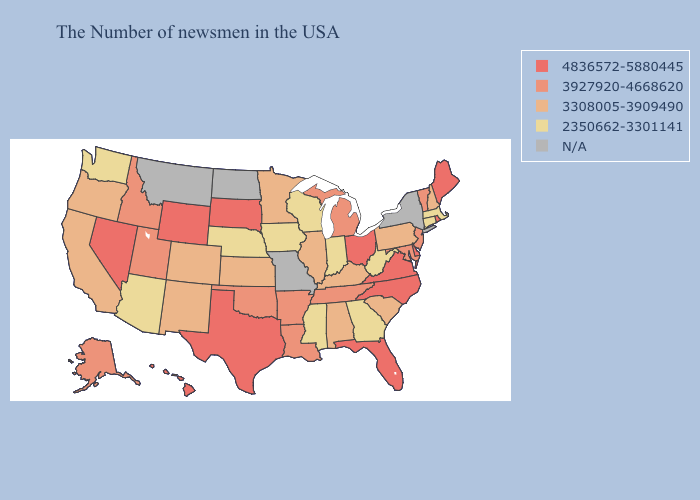What is the highest value in states that border Louisiana?
Concise answer only. 4836572-5880445. Name the states that have a value in the range 3308005-3909490?
Quick response, please. New Hampshire, Pennsylvania, South Carolina, Kentucky, Alabama, Illinois, Minnesota, Kansas, Colorado, New Mexico, California, Oregon. Does the map have missing data?
Write a very short answer. Yes. Among the states that border Indiana , which have the highest value?
Quick response, please. Ohio. Name the states that have a value in the range N/A?
Concise answer only. New York, Missouri, North Dakota, Montana. What is the lowest value in the South?
Short answer required. 2350662-3301141. What is the value of Delaware?
Answer briefly. 4836572-5880445. Does the first symbol in the legend represent the smallest category?
Quick response, please. No. What is the value of Iowa?
Short answer required. 2350662-3301141. What is the value of Hawaii?
Write a very short answer. 4836572-5880445. Name the states that have a value in the range 3308005-3909490?
Answer briefly. New Hampshire, Pennsylvania, South Carolina, Kentucky, Alabama, Illinois, Minnesota, Kansas, Colorado, New Mexico, California, Oregon. What is the value of Wyoming?
Give a very brief answer. 4836572-5880445. Name the states that have a value in the range 3308005-3909490?
Concise answer only. New Hampshire, Pennsylvania, South Carolina, Kentucky, Alabama, Illinois, Minnesota, Kansas, Colorado, New Mexico, California, Oregon. 